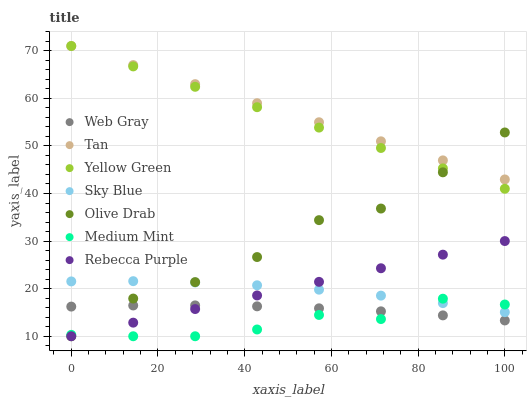Does Medium Mint have the minimum area under the curve?
Answer yes or no. Yes. Does Tan have the maximum area under the curve?
Answer yes or no. Yes. Does Web Gray have the minimum area under the curve?
Answer yes or no. No. Does Web Gray have the maximum area under the curve?
Answer yes or no. No. Is Rebecca Purple the smoothest?
Answer yes or no. Yes. Is Olive Drab the roughest?
Answer yes or no. Yes. Is Web Gray the smoothest?
Answer yes or no. No. Is Web Gray the roughest?
Answer yes or no. No. Does Medium Mint have the lowest value?
Answer yes or no. Yes. Does Web Gray have the lowest value?
Answer yes or no. No. Does Tan have the highest value?
Answer yes or no. Yes. Does Web Gray have the highest value?
Answer yes or no. No. Is Web Gray less than Yellow Green?
Answer yes or no. Yes. Is Yellow Green greater than Web Gray?
Answer yes or no. Yes. Does Sky Blue intersect Medium Mint?
Answer yes or no. Yes. Is Sky Blue less than Medium Mint?
Answer yes or no. No. Is Sky Blue greater than Medium Mint?
Answer yes or no. No. Does Web Gray intersect Yellow Green?
Answer yes or no. No. 